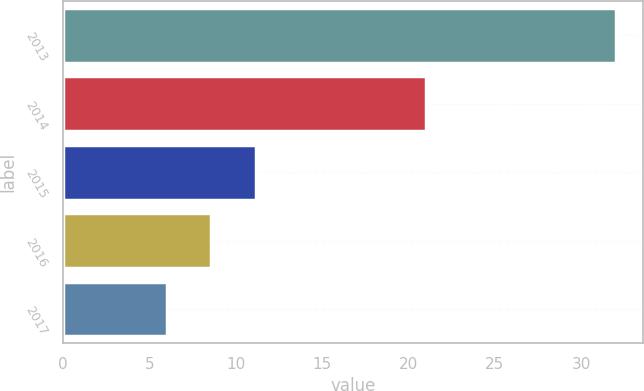Convert chart to OTSL. <chart><loc_0><loc_0><loc_500><loc_500><bar_chart><fcel>2013<fcel>2014<fcel>2015<fcel>2016<fcel>2017<nl><fcel>32<fcel>21<fcel>11.2<fcel>8.6<fcel>6<nl></chart> 